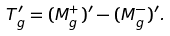<formula> <loc_0><loc_0><loc_500><loc_500>T _ { g } ^ { \prime } = ( M _ { g } ^ { + } ) ^ { \prime } - ( M _ { g } ^ { - } ) ^ { \prime } .</formula> 